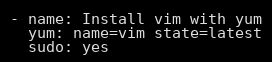Convert code to text. <code><loc_0><loc_0><loc_500><loc_500><_YAML_>- name: Install vim with yum
  yum: name=vim state=latest
  sudo: yes
</code> 